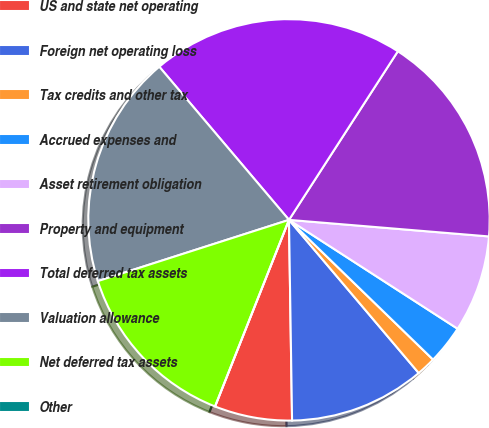<chart> <loc_0><loc_0><loc_500><loc_500><pie_chart><fcel>US and state net operating<fcel>Foreign net operating loss<fcel>Tax credits and other tax<fcel>Accrued expenses and<fcel>Asset retirement obligation<fcel>Property and equipment<fcel>Total deferred tax assets<fcel>Valuation allowance<fcel>Net deferred tax assets<fcel>Other<nl><fcel>6.25%<fcel>10.94%<fcel>1.56%<fcel>3.13%<fcel>7.81%<fcel>17.19%<fcel>20.31%<fcel>18.75%<fcel>14.06%<fcel>0.0%<nl></chart> 